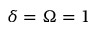<formula> <loc_0><loc_0><loc_500><loc_500>\delta = \Omega = 1</formula> 